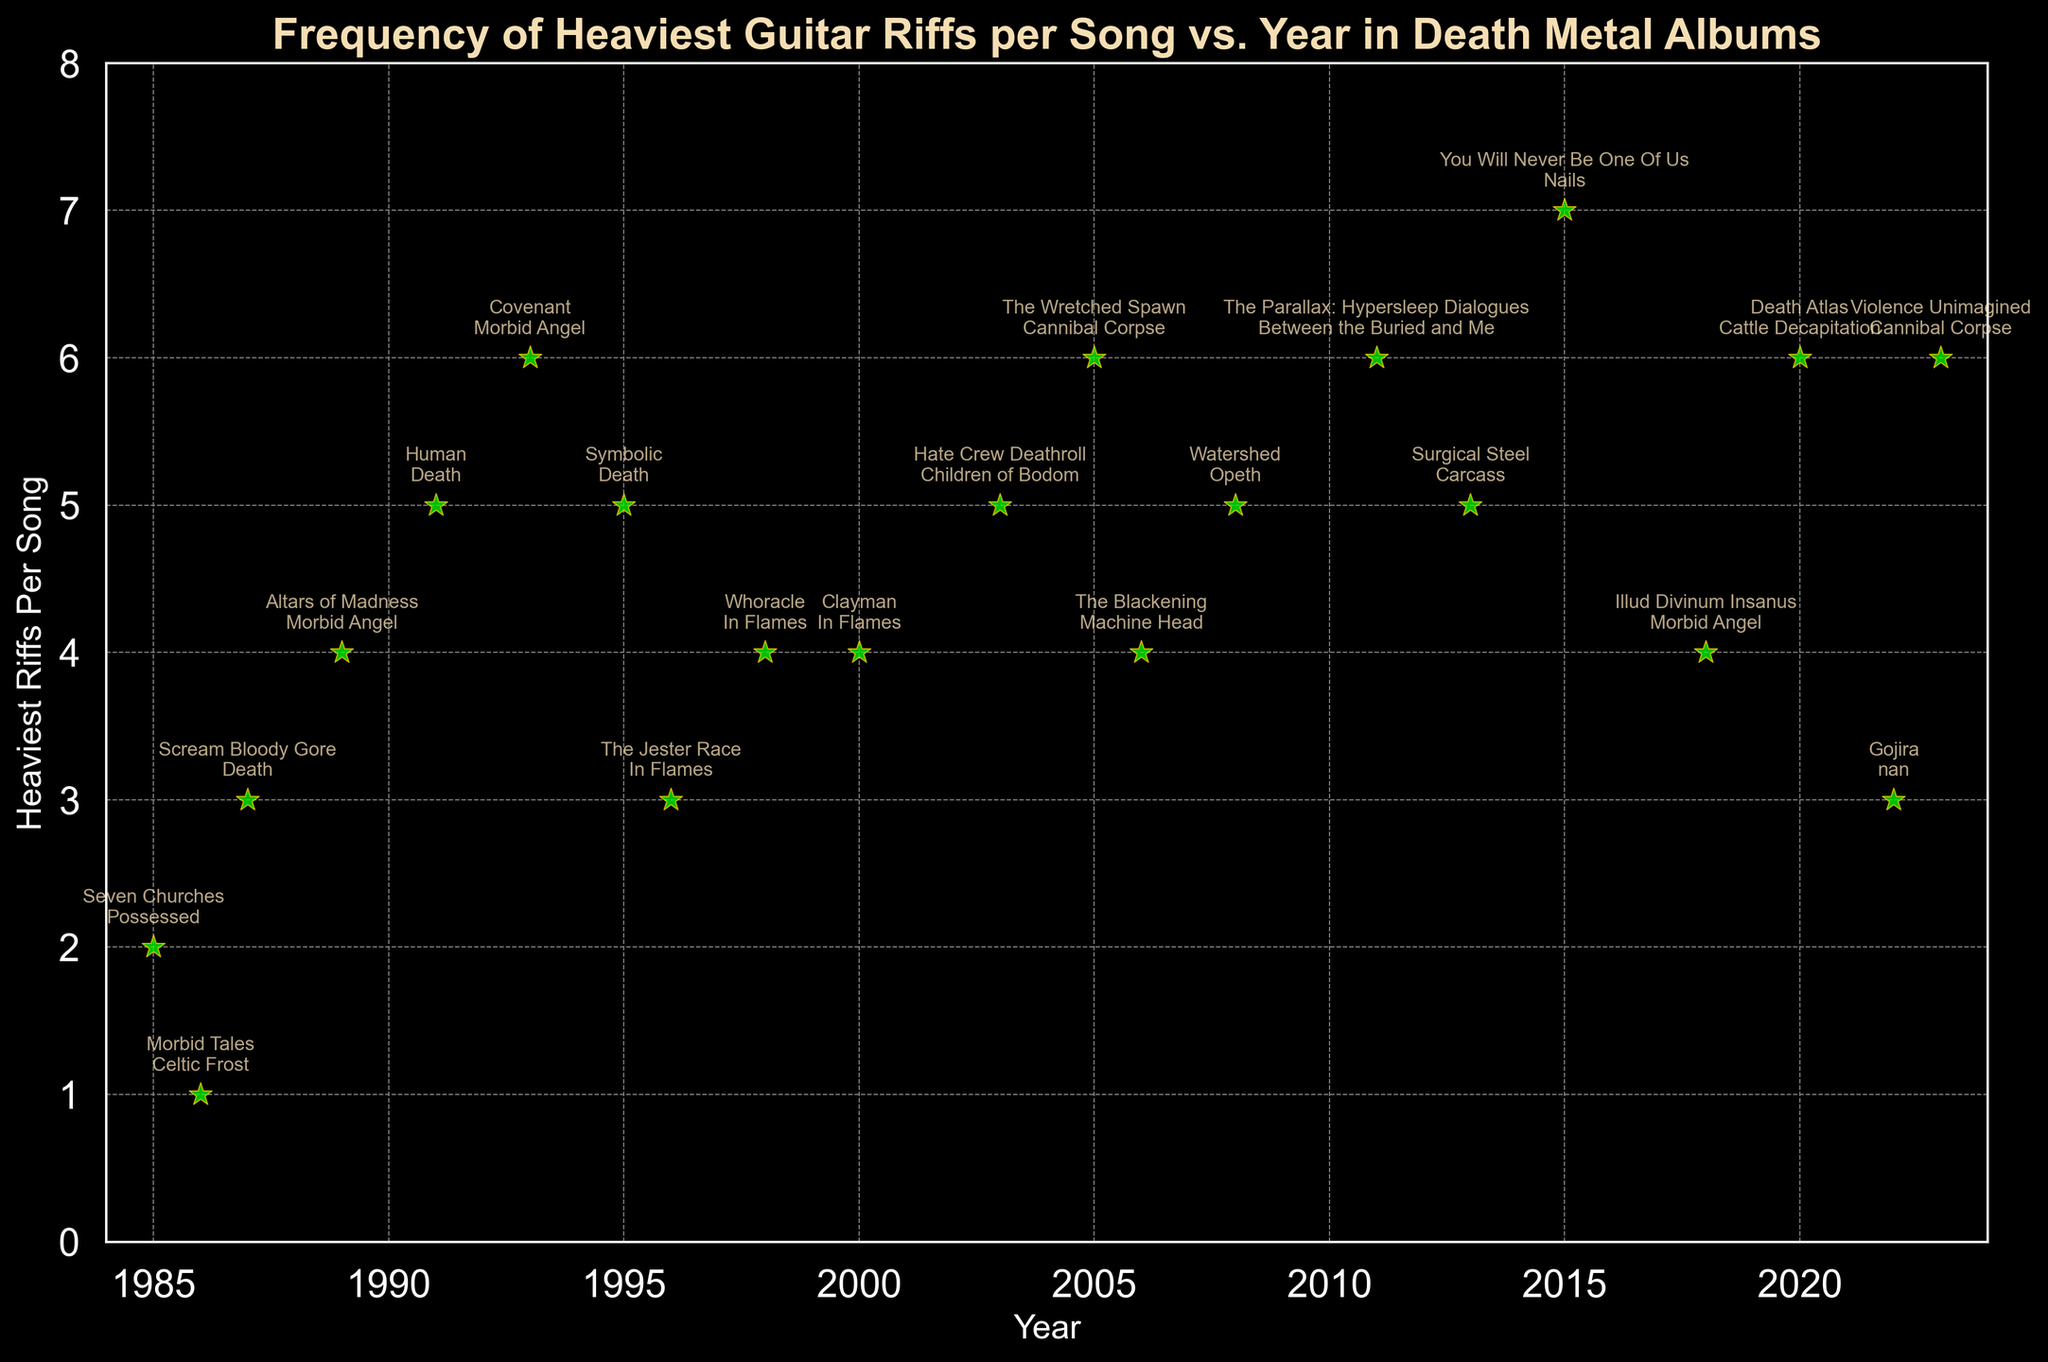What's the latest year featured in the plot? The x-axis represents the years, and the latest value on this axis will represent the most recent year.
Answer: 2023 Which album has the highest frequency of heaviest riffs per song, and what is that frequency? The y-axis represents the 'Heaviest Riffs Per Song' and the highest point on this axis indicates the album with the highest frequency.
Answer: You Will Never Be One Of Us, 7 How many albums have a frequency of heaviest riffs per song equal to 6? By examining the y-axis values and counting the number of points that exist at '6', we can determine the total.
Answer: 5 Which year features the highest concentration of albums? Identify the year with the highest number of points vertically aligned.
Answer: 2005 and 2023 (it's a tie, each has 2 albums) What is the average number of heaviest riffs per song for the albums released in the 1990s? Identify albums from the 1990s, sum their riff frequencies, and divide by the number of these albums. The 1990s include albums from years 1991, 1993, 1995, 1996, and 1998. The riff frequencies are 5, 6, 5, 3, and 4 respectively. Sum is 5+6+5+3+4=23, then divide by 5.
Answer: 4.6 Compare the frequency of heaviest riffs per song between 'Symbolic' and 'The Blackening'. Which album has more riffs per song? Locate both albums on the scatter plot and compare their y-values. 'Symbolic' has a y-value of 5 and 'The Blackening' has a y-value of 4.
Answer: Symbolic What is the average frequency of heaviest riffs per song for Death Metal albums released after 2010? Identify albums released after 2010, sum their riff frequencies, and divide by the number of these albums. These albums are from 2011, 2013, 2015, 2018, 2020, 2022, 2023 with frequencies of 6, 5, 7, 4, 6, 3, 6 respectively. The sum is 6+5+7+4+6+3+6=37, then divide by 7.
Answer: 5.3 